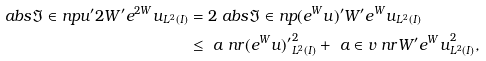<formula> <loc_0><loc_0><loc_500><loc_500>\ a b s { \Im \in n p { u ^ { \prime } } { 2 W ^ { \prime } e ^ { 2 W } u } _ { L ^ { 2 } ( I ) } } & = 2 \ a b s { \Im \in n p { ( e ^ { W } u ) ^ { \prime } } { W ^ { \prime } e ^ { W } u } _ { L ^ { 2 } ( I ) } } \\ & \leq \ a \ n r { ( e ^ { W } u ) ^ { \prime } } ^ { 2 } _ { L ^ { 2 } ( I ) } + \ a \in v \ n r { W ^ { \prime } e ^ { W } u } ^ { 2 } _ { L ^ { 2 } ( I ) } ,</formula> 